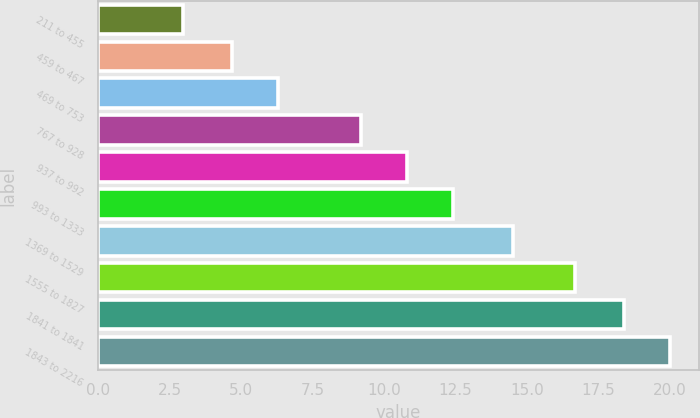<chart> <loc_0><loc_0><loc_500><loc_500><bar_chart><fcel>211 to 455<fcel>459 to 467<fcel>469 to 753<fcel>767 to 928<fcel>937 to 992<fcel>993 to 1333<fcel>1369 to 1529<fcel>1555 to 1827<fcel>1841 to 1841<fcel>1843 to 2216<nl><fcel>2.96<fcel>4.67<fcel>6.28<fcel>9.18<fcel>10.79<fcel>12.4<fcel>14.51<fcel>16.67<fcel>18.41<fcel>20.02<nl></chart> 